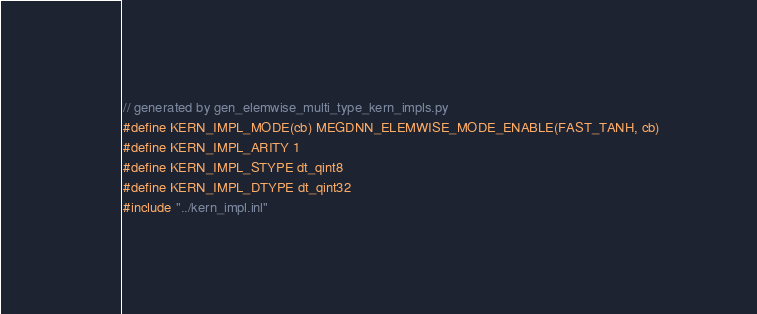<code> <loc_0><loc_0><loc_500><loc_500><_Cuda_>// generated by gen_elemwise_multi_type_kern_impls.py
#define KERN_IMPL_MODE(cb) MEGDNN_ELEMWISE_MODE_ENABLE(FAST_TANH, cb)
#define KERN_IMPL_ARITY 1
#define KERN_IMPL_STYPE dt_qint8
#define KERN_IMPL_DTYPE dt_qint32
#include "../kern_impl.inl"
</code> 